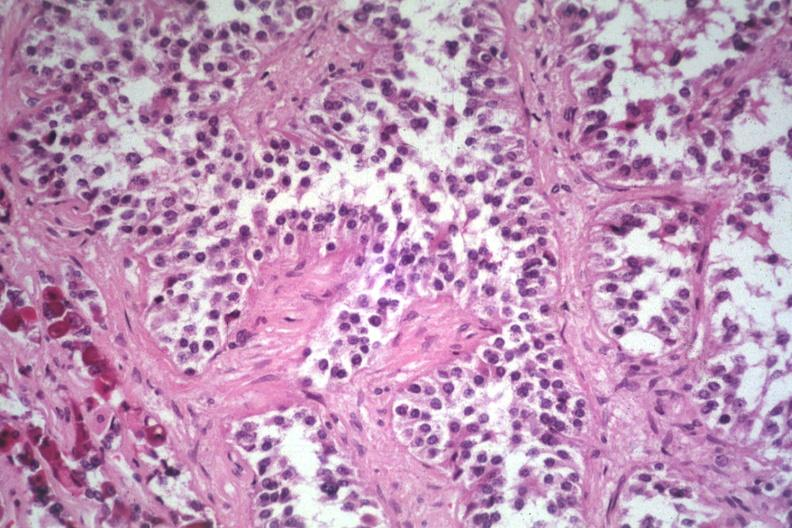s pituitary present?
Answer the question using a single word or phrase. Yes 